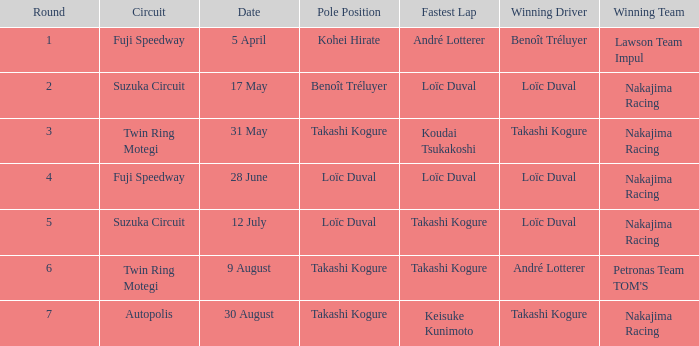During which earlier round was takashi kogure's fastest lap recorded? 5.0. 